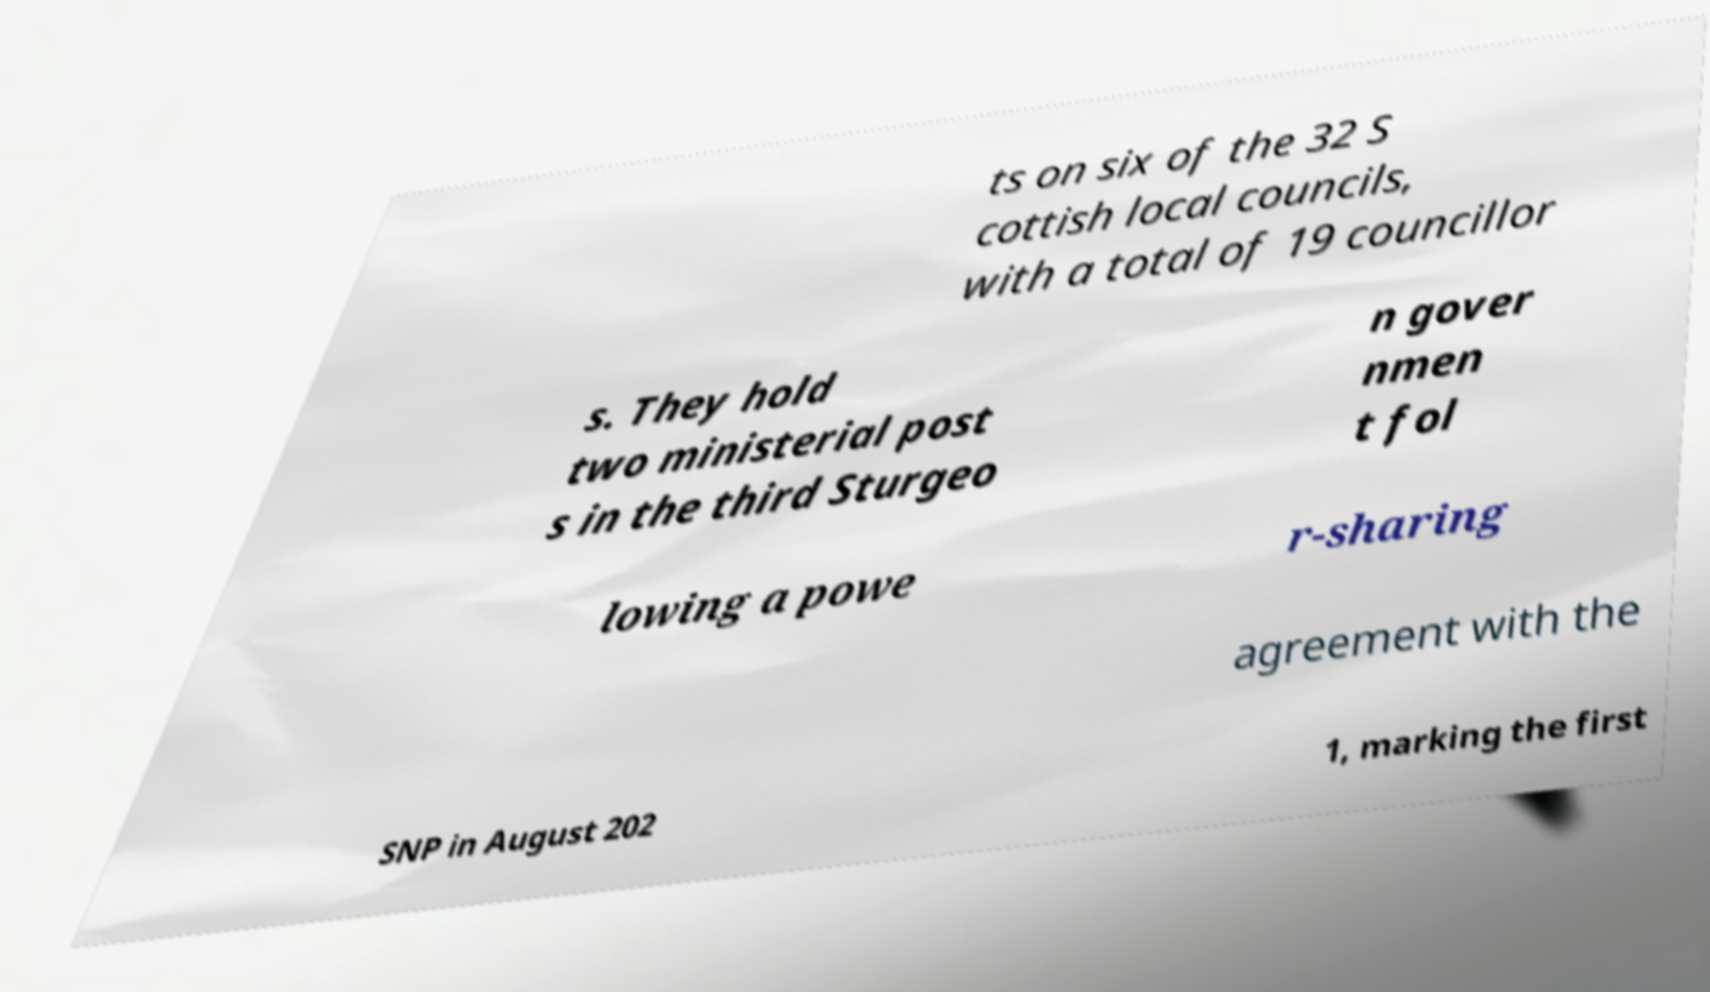There's text embedded in this image that I need extracted. Can you transcribe it verbatim? ts on six of the 32 S cottish local councils, with a total of 19 councillor s. They hold two ministerial post s in the third Sturgeo n gover nmen t fol lowing a powe r-sharing agreement with the SNP in August 202 1, marking the first 